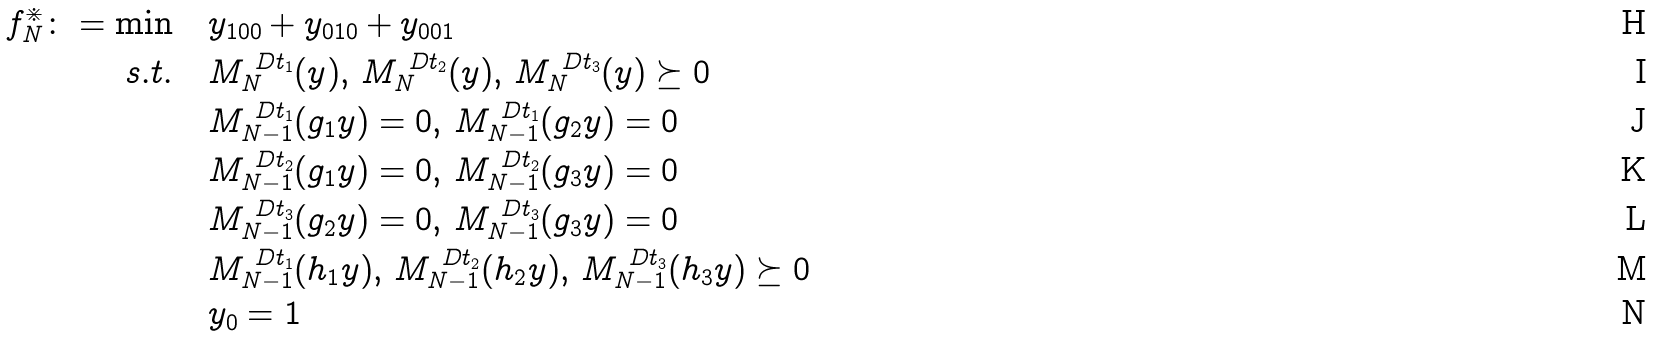Convert formula to latex. <formula><loc_0><loc_0><loc_500><loc_500>f ^ { \divideontimes } _ { N } \colon = \min & \quad y _ { 1 0 0 } + y _ { 0 1 0 } + y _ { 0 0 1 } \\ s . t . & \quad M _ { N } ^ { \ D t _ { 1 } } ( y ) , \, M _ { N } ^ { \ D t _ { 2 } } ( y ) , \, M _ { N } ^ { \ D t _ { 3 } } ( y ) \succeq 0 \\ & \quad M _ { N - 1 } ^ { \ D t _ { 1 } } ( g _ { 1 } y ) = 0 , \, M _ { N - 1 } ^ { \ D t _ { 1 } } ( g _ { 2 } y ) = 0 \\ & \quad M _ { N - 1 } ^ { \ D t _ { 2 } } ( g _ { 1 } y ) = 0 , \, M _ { N - 1 } ^ { \ D t _ { 2 } } ( g _ { 3 } y ) = 0 \\ & \quad M _ { N - 1 } ^ { \ D t _ { 3 } } ( g _ { 2 } y ) = 0 , \, M _ { N - 1 } ^ { \ D t _ { 3 } } ( g _ { 3 } y ) = 0 \\ & \quad M _ { N - 1 } ^ { \ D t _ { 1 } } ( h _ { 1 } y ) , \, M _ { N - 1 } ^ { \ D t _ { 2 } } ( h _ { 2 } y ) , \, M _ { N - 1 } ^ { \ D t _ { 3 } } ( h _ { 3 } y ) \succeq 0 \\ & \quad y _ { 0 } = 1</formula> 